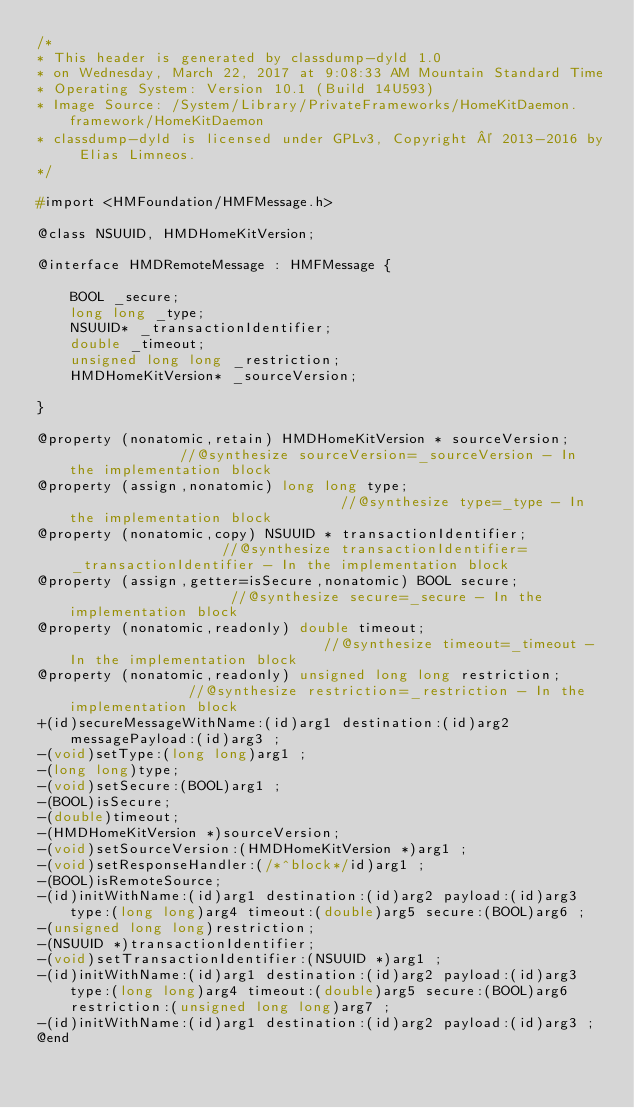Convert code to text. <code><loc_0><loc_0><loc_500><loc_500><_C_>/*
* This header is generated by classdump-dyld 1.0
* on Wednesday, March 22, 2017 at 9:08:33 AM Mountain Standard Time
* Operating System: Version 10.1 (Build 14U593)
* Image Source: /System/Library/PrivateFrameworks/HomeKitDaemon.framework/HomeKitDaemon
* classdump-dyld is licensed under GPLv3, Copyright © 2013-2016 by Elias Limneos.
*/

#import <HMFoundation/HMFMessage.h>

@class NSUUID, HMDHomeKitVersion;

@interface HMDRemoteMessage : HMFMessage {

	BOOL _secure;
	long long _type;
	NSUUID* _transactionIdentifier;
	double _timeout;
	unsigned long long _restriction;
	HMDHomeKitVersion* _sourceVersion;

}

@property (nonatomic,retain) HMDHomeKitVersion * sourceVersion;              //@synthesize sourceVersion=_sourceVersion - In the implementation block
@property (assign,nonatomic) long long type;                                 //@synthesize type=_type - In the implementation block
@property (nonatomic,copy) NSUUID * transactionIdentifier;                   //@synthesize transactionIdentifier=_transactionIdentifier - In the implementation block
@property (assign,getter=isSecure,nonatomic) BOOL secure;                    //@synthesize secure=_secure - In the implementation block
@property (nonatomic,readonly) double timeout;                               //@synthesize timeout=_timeout - In the implementation block
@property (nonatomic,readonly) unsigned long long restriction;               //@synthesize restriction=_restriction - In the implementation block
+(id)secureMessageWithName:(id)arg1 destination:(id)arg2 messagePayload:(id)arg3 ;
-(void)setType:(long long)arg1 ;
-(long long)type;
-(void)setSecure:(BOOL)arg1 ;
-(BOOL)isSecure;
-(double)timeout;
-(HMDHomeKitVersion *)sourceVersion;
-(void)setSourceVersion:(HMDHomeKitVersion *)arg1 ;
-(void)setResponseHandler:(/*^block*/id)arg1 ;
-(BOOL)isRemoteSource;
-(id)initWithName:(id)arg1 destination:(id)arg2 payload:(id)arg3 type:(long long)arg4 timeout:(double)arg5 secure:(BOOL)arg6 ;
-(unsigned long long)restriction;
-(NSUUID *)transactionIdentifier;
-(void)setTransactionIdentifier:(NSUUID *)arg1 ;
-(id)initWithName:(id)arg1 destination:(id)arg2 payload:(id)arg3 type:(long long)arg4 timeout:(double)arg5 secure:(BOOL)arg6 restriction:(unsigned long long)arg7 ;
-(id)initWithName:(id)arg1 destination:(id)arg2 payload:(id)arg3 ;
@end

</code> 